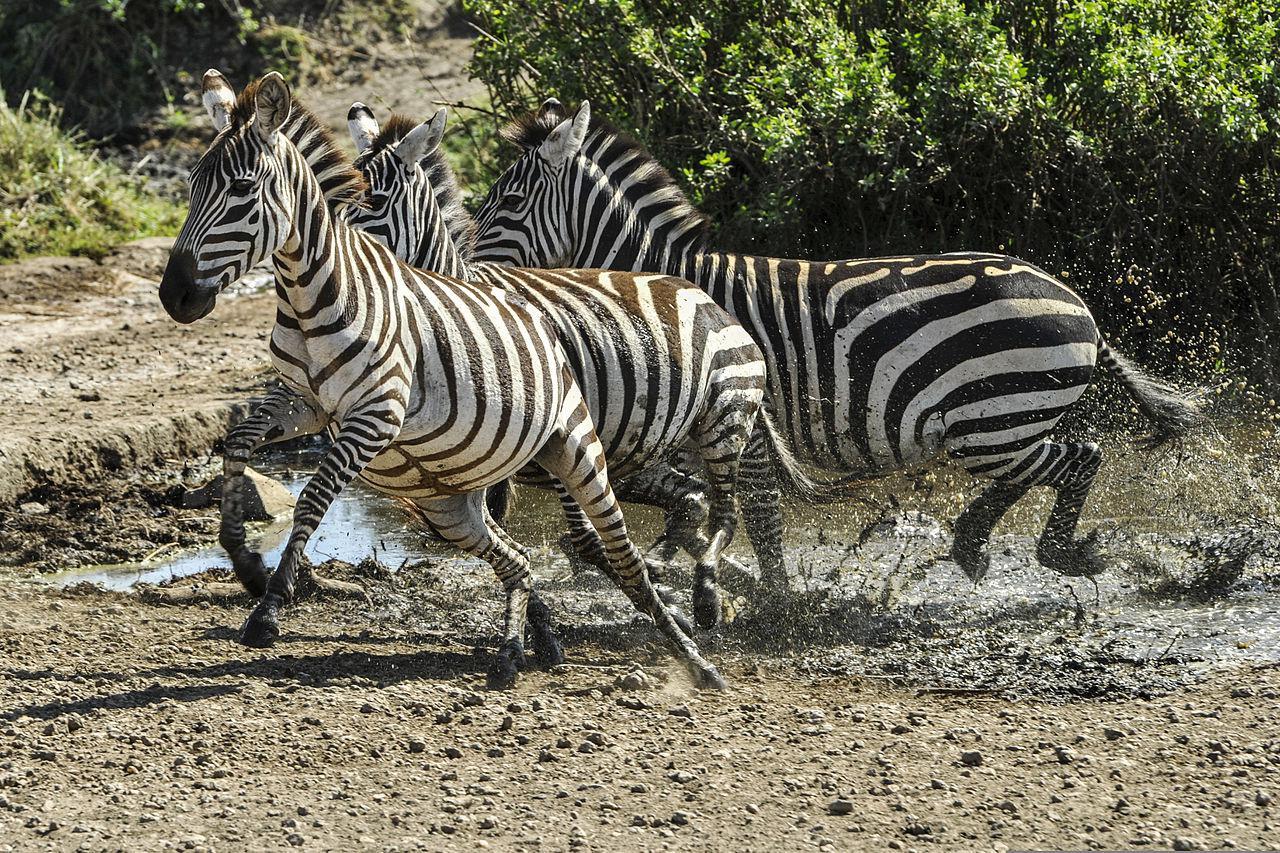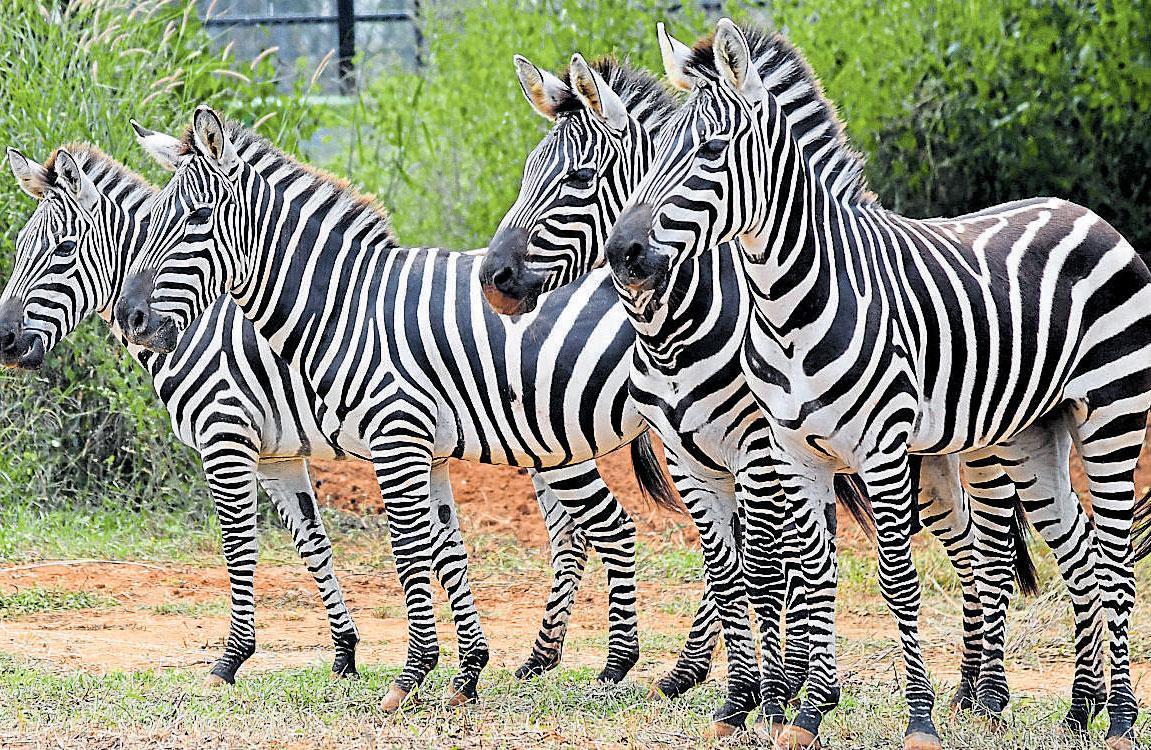The first image is the image on the left, the second image is the image on the right. Considering the images on both sides, is "All the zebras are running." valid? Answer yes or no. No. The first image is the image on the left, the second image is the image on the right. For the images shown, is this caption "Nine or fewer zebras are present." true? Answer yes or no. Yes. 